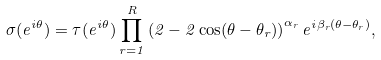<formula> <loc_0><loc_0><loc_500><loc_500>\sigma ( e ^ { i \theta } ) = \tau ( e ^ { i \theta } ) \prod _ { r = 1 } ^ { R } \left ( 2 - 2 \cos ( \theta - \theta _ { r } ) \right ) ^ { \alpha _ { r } } e ^ { i \beta _ { r } ( \theta - \theta _ { r } ) } ,</formula> 